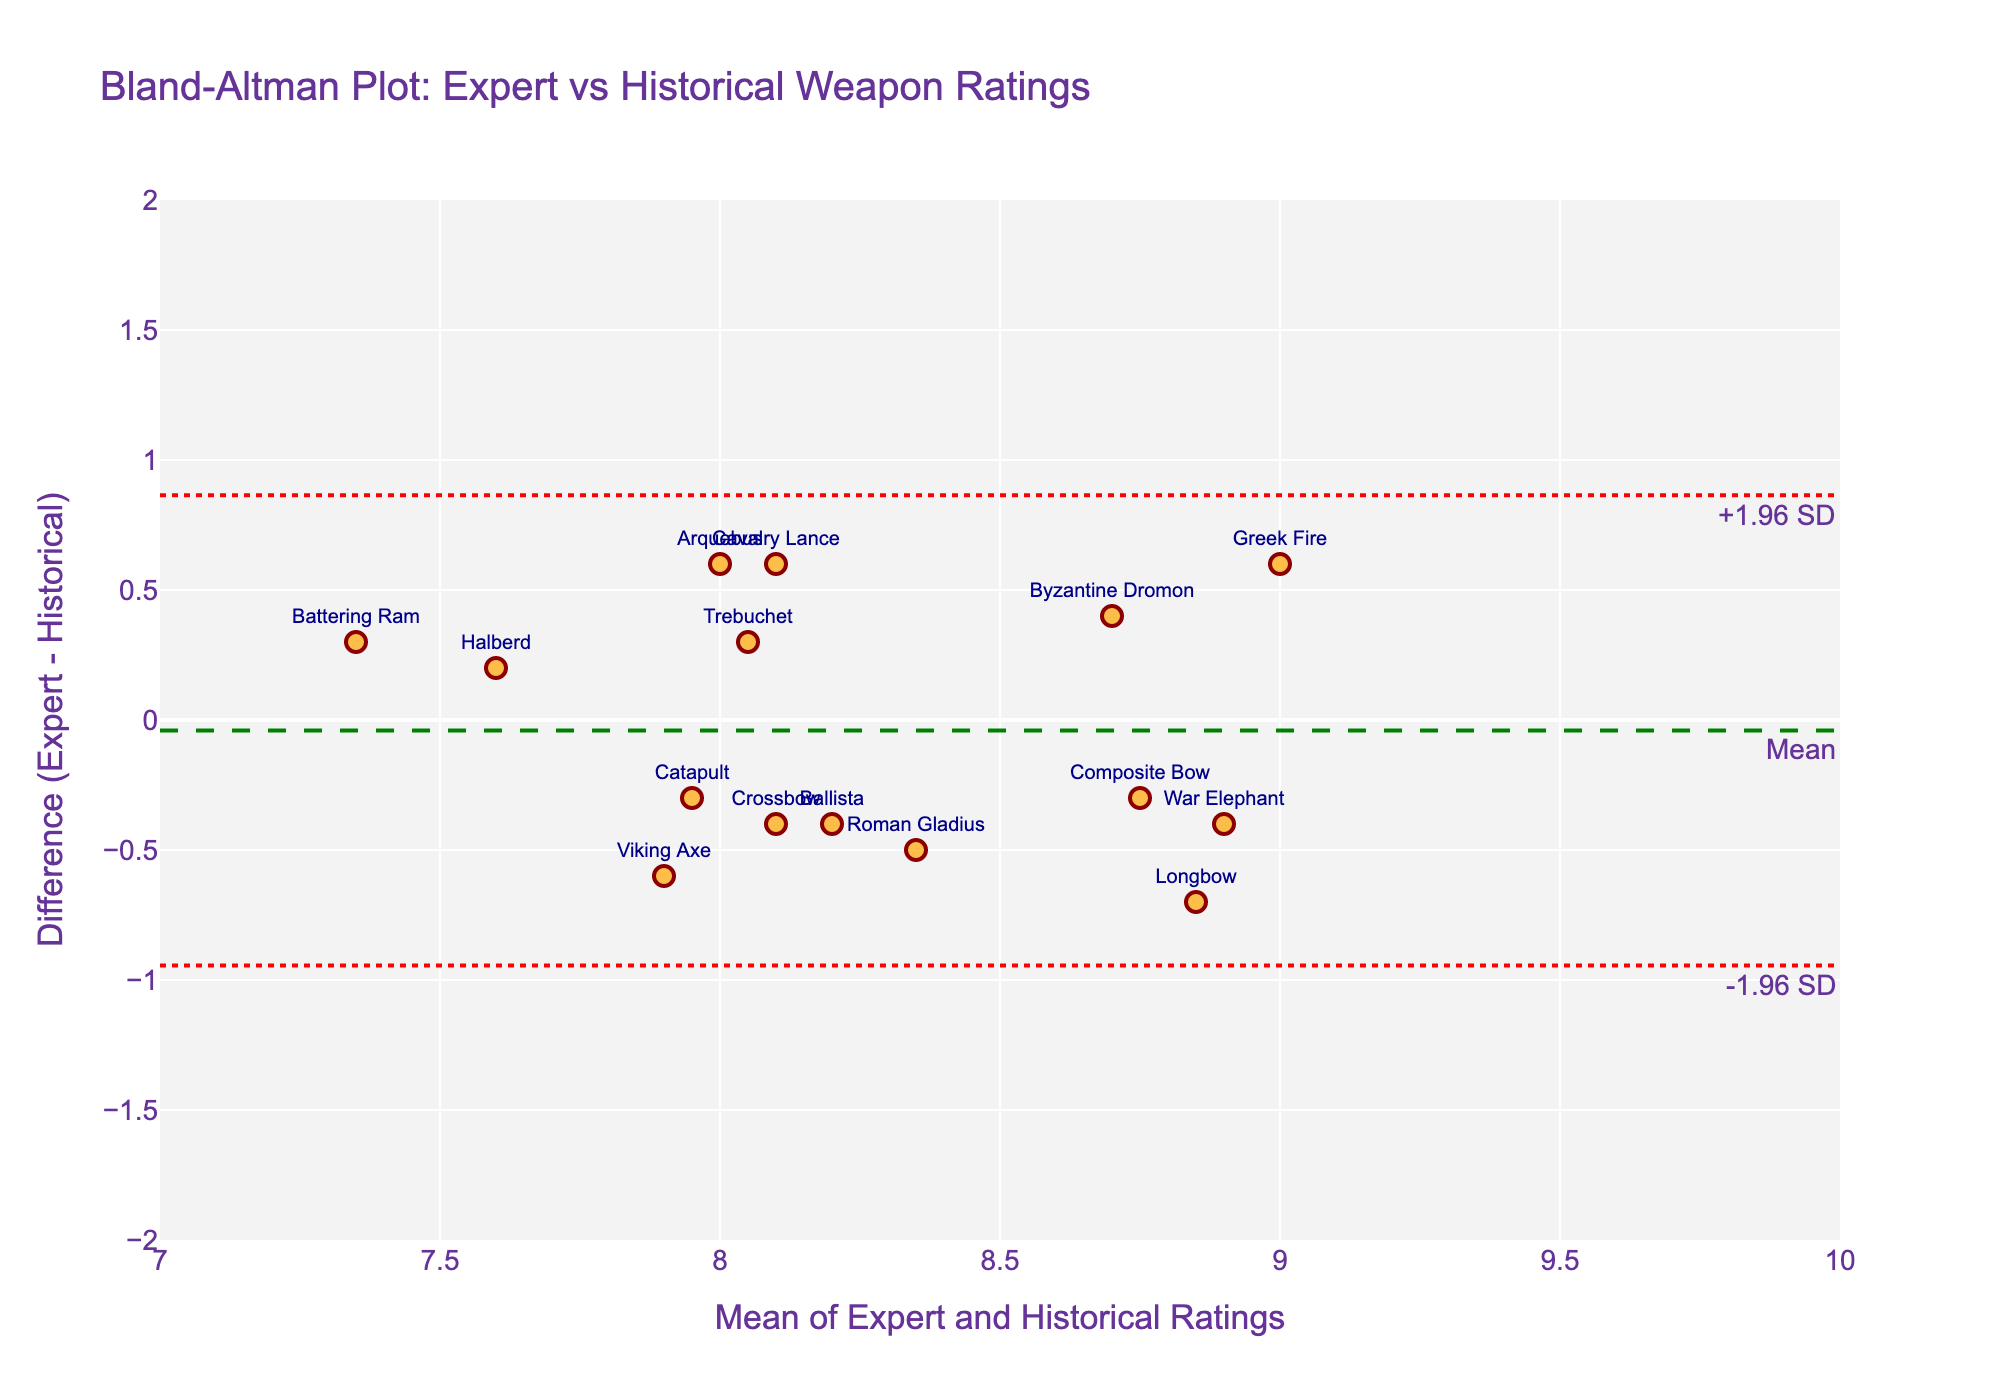What is the title of the plot? The title is located at the top of the plot and typically provides an overview of what the plot displays.
Answer: Bland-Altman Plot: Expert vs Historical Weapon Ratings What color are the markers representing the weapons? The color of the markers can be seen in the plot legend or by looking at the data points themselves. They are a shade of orange with dark red outlines.
Answer: Orange How many weapons are shown in the plot? Each marker represents a weapon, and the total number can be counted from the markers identified by labels.
Answer: 15 What is the mean difference line color and its annotation text? The mean difference line is displayed across the plot, and its color and annotation text can be found on the line itself. The line is green, and the annotation is "Mean."
Answer: Green, Mean Which weapon has the highest difference between expert and historical ratings? To find this, look at the y-axis values and find the highest point where the markers are labeled with weapon names. The weapon at the highest y-axis value indicates the greatest difference.
Answer: Greek Fire What's the range of values on the x-axis? The range of the x-axis can be observed from the start and end values displayed on the axis itself.
Answer: 7 to 10 What's the range of values on the y-axis? The range of the y-axis can be observed from the start and end values displayed on the axis itself.
Answer: -2 to 2 What are the upper and lower limits of agreement's y-axis values? The limits of agreement are displayed as dotted lines on the plot, and their values can be seen where these lines intercept the y-axis.
Answer: Around 1.1 and -1.1 Which weapon falls closest to the mean difference line? The mean difference line is marked on the plot, and the weapon closest to this line can be identified by its label.
Answer: Halberd Comparing the Composite Bow and the Trebuchet, which has a higher expert rating compared to the historical rating, and by how much? The plot shows the difference (Expert - Historical) for each weapon. The distance between the data point and the horizontal line at zero indicates the magnitude and direction of this difference. Composite Bow has a difference above the line, and Trebuchet below it. Composite Bow's expert rating is 0.3 higher.
Answer: Composite Bow, 0.3 